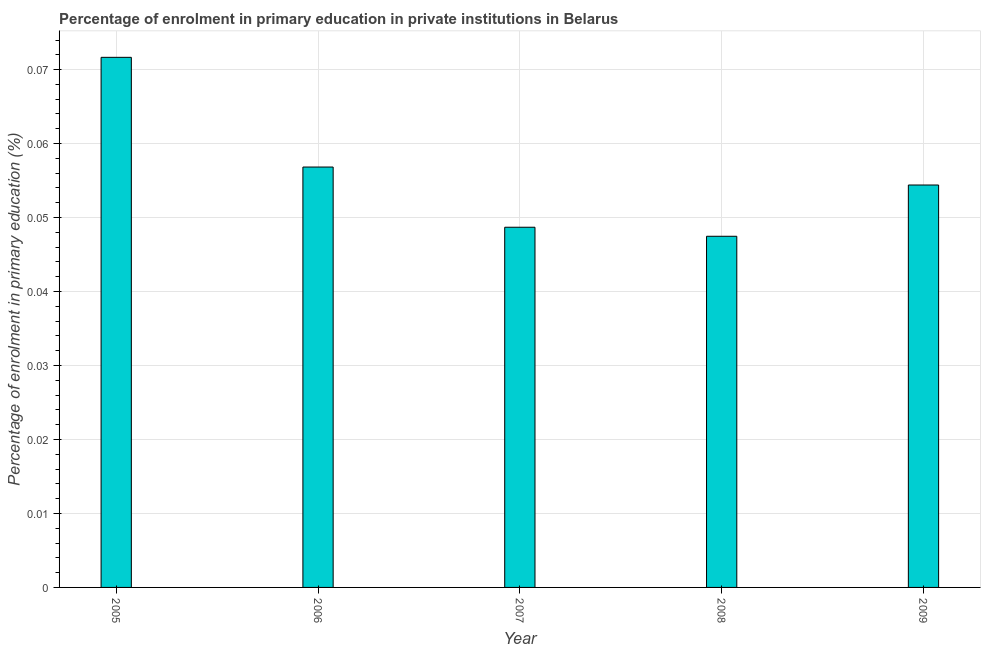Does the graph contain any zero values?
Make the answer very short. No. What is the title of the graph?
Give a very brief answer. Percentage of enrolment in primary education in private institutions in Belarus. What is the label or title of the Y-axis?
Give a very brief answer. Percentage of enrolment in primary education (%). What is the enrolment percentage in primary education in 2008?
Make the answer very short. 0.05. Across all years, what is the maximum enrolment percentage in primary education?
Make the answer very short. 0.07. Across all years, what is the minimum enrolment percentage in primary education?
Provide a succinct answer. 0.05. In which year was the enrolment percentage in primary education minimum?
Your answer should be compact. 2008. What is the sum of the enrolment percentage in primary education?
Your answer should be very brief. 0.28. What is the difference between the enrolment percentage in primary education in 2007 and 2009?
Your response must be concise. -0.01. What is the average enrolment percentage in primary education per year?
Offer a very short reply. 0.06. What is the median enrolment percentage in primary education?
Make the answer very short. 0.05. What is the ratio of the enrolment percentage in primary education in 2005 to that in 2009?
Offer a very short reply. 1.32. Is the enrolment percentage in primary education in 2006 less than that in 2009?
Your response must be concise. No. Is the difference between the enrolment percentage in primary education in 2005 and 2008 greater than the difference between any two years?
Your answer should be compact. Yes. What is the difference between the highest and the second highest enrolment percentage in primary education?
Make the answer very short. 0.01. In how many years, is the enrolment percentage in primary education greater than the average enrolment percentage in primary education taken over all years?
Provide a short and direct response. 2. What is the difference between two consecutive major ticks on the Y-axis?
Ensure brevity in your answer.  0.01. Are the values on the major ticks of Y-axis written in scientific E-notation?
Offer a very short reply. No. What is the Percentage of enrolment in primary education (%) in 2005?
Offer a terse response. 0.07. What is the Percentage of enrolment in primary education (%) of 2006?
Your response must be concise. 0.06. What is the Percentage of enrolment in primary education (%) of 2007?
Offer a very short reply. 0.05. What is the Percentage of enrolment in primary education (%) of 2008?
Provide a succinct answer. 0.05. What is the Percentage of enrolment in primary education (%) of 2009?
Your answer should be very brief. 0.05. What is the difference between the Percentage of enrolment in primary education (%) in 2005 and 2006?
Keep it short and to the point. 0.01. What is the difference between the Percentage of enrolment in primary education (%) in 2005 and 2007?
Offer a very short reply. 0.02. What is the difference between the Percentage of enrolment in primary education (%) in 2005 and 2008?
Keep it short and to the point. 0.02. What is the difference between the Percentage of enrolment in primary education (%) in 2005 and 2009?
Make the answer very short. 0.02. What is the difference between the Percentage of enrolment in primary education (%) in 2006 and 2007?
Your answer should be compact. 0.01. What is the difference between the Percentage of enrolment in primary education (%) in 2006 and 2008?
Give a very brief answer. 0.01. What is the difference between the Percentage of enrolment in primary education (%) in 2006 and 2009?
Provide a succinct answer. 0. What is the difference between the Percentage of enrolment in primary education (%) in 2007 and 2008?
Keep it short and to the point. 0. What is the difference between the Percentage of enrolment in primary education (%) in 2007 and 2009?
Give a very brief answer. -0.01. What is the difference between the Percentage of enrolment in primary education (%) in 2008 and 2009?
Your response must be concise. -0.01. What is the ratio of the Percentage of enrolment in primary education (%) in 2005 to that in 2006?
Make the answer very short. 1.26. What is the ratio of the Percentage of enrolment in primary education (%) in 2005 to that in 2007?
Provide a short and direct response. 1.47. What is the ratio of the Percentage of enrolment in primary education (%) in 2005 to that in 2008?
Your answer should be compact. 1.51. What is the ratio of the Percentage of enrolment in primary education (%) in 2005 to that in 2009?
Provide a short and direct response. 1.32. What is the ratio of the Percentage of enrolment in primary education (%) in 2006 to that in 2007?
Keep it short and to the point. 1.17. What is the ratio of the Percentage of enrolment in primary education (%) in 2006 to that in 2008?
Your answer should be very brief. 1.2. What is the ratio of the Percentage of enrolment in primary education (%) in 2006 to that in 2009?
Make the answer very short. 1.04. What is the ratio of the Percentage of enrolment in primary education (%) in 2007 to that in 2008?
Your answer should be very brief. 1.03. What is the ratio of the Percentage of enrolment in primary education (%) in 2007 to that in 2009?
Your response must be concise. 0.9. What is the ratio of the Percentage of enrolment in primary education (%) in 2008 to that in 2009?
Keep it short and to the point. 0.87. 